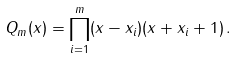<formula> <loc_0><loc_0><loc_500><loc_500>Q _ { m } ( x ) = \prod _ { i = 1 } ^ { m } ( x - x _ { i } ) ( x + x _ { i } + 1 ) \, .</formula> 